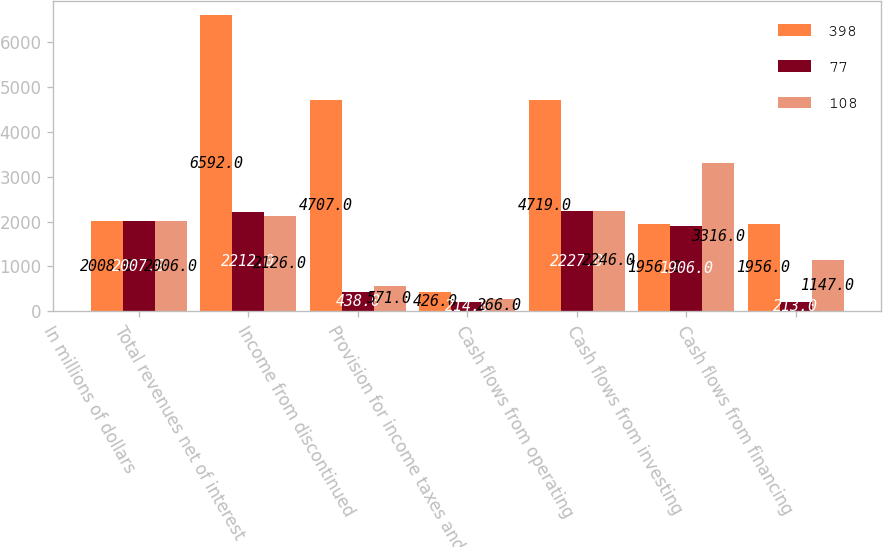Convert chart to OTSL. <chart><loc_0><loc_0><loc_500><loc_500><stacked_bar_chart><ecel><fcel>In millions of dollars<fcel>Total revenues net of interest<fcel>Income from discontinued<fcel>Provision for income taxes and<fcel>Cash flows from operating<fcel>Cash flows from investing<fcel>Cash flows from financing<nl><fcel>398<fcel>2008<fcel>6592<fcel>4707<fcel>426<fcel>4719<fcel>1956<fcel>1956<nl><fcel>77<fcel>2007<fcel>2212<fcel>438<fcel>214<fcel>2227<fcel>1906<fcel>213<nl><fcel>108<fcel>2006<fcel>2126<fcel>571<fcel>266<fcel>2246<fcel>3316<fcel>1147<nl></chart> 